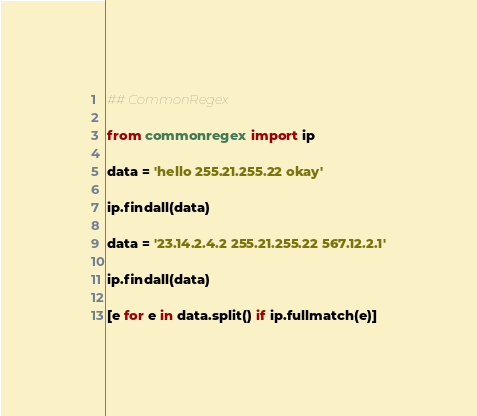<code> <loc_0><loc_0><loc_500><loc_500><_Python_>## CommonRegex

from commonregex import ip

data = 'hello 255.21.255.22 okay'

ip.findall(data)

data = '23.14.2.4.2 255.21.255.22 567.12.2.1'

ip.findall(data)

[e for e in data.split() if ip.fullmatch(e)]

</code> 